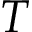<formula> <loc_0><loc_0><loc_500><loc_500>T</formula> 